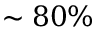<formula> <loc_0><loc_0><loc_500><loc_500>\sim 8 0 \%</formula> 